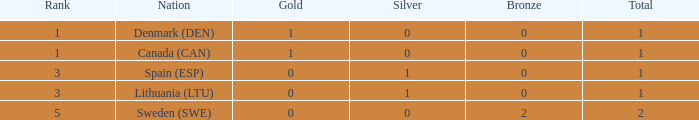What is the position when there is 0 gold, the overall sum is greater than 1, and silver is above 0? None. 